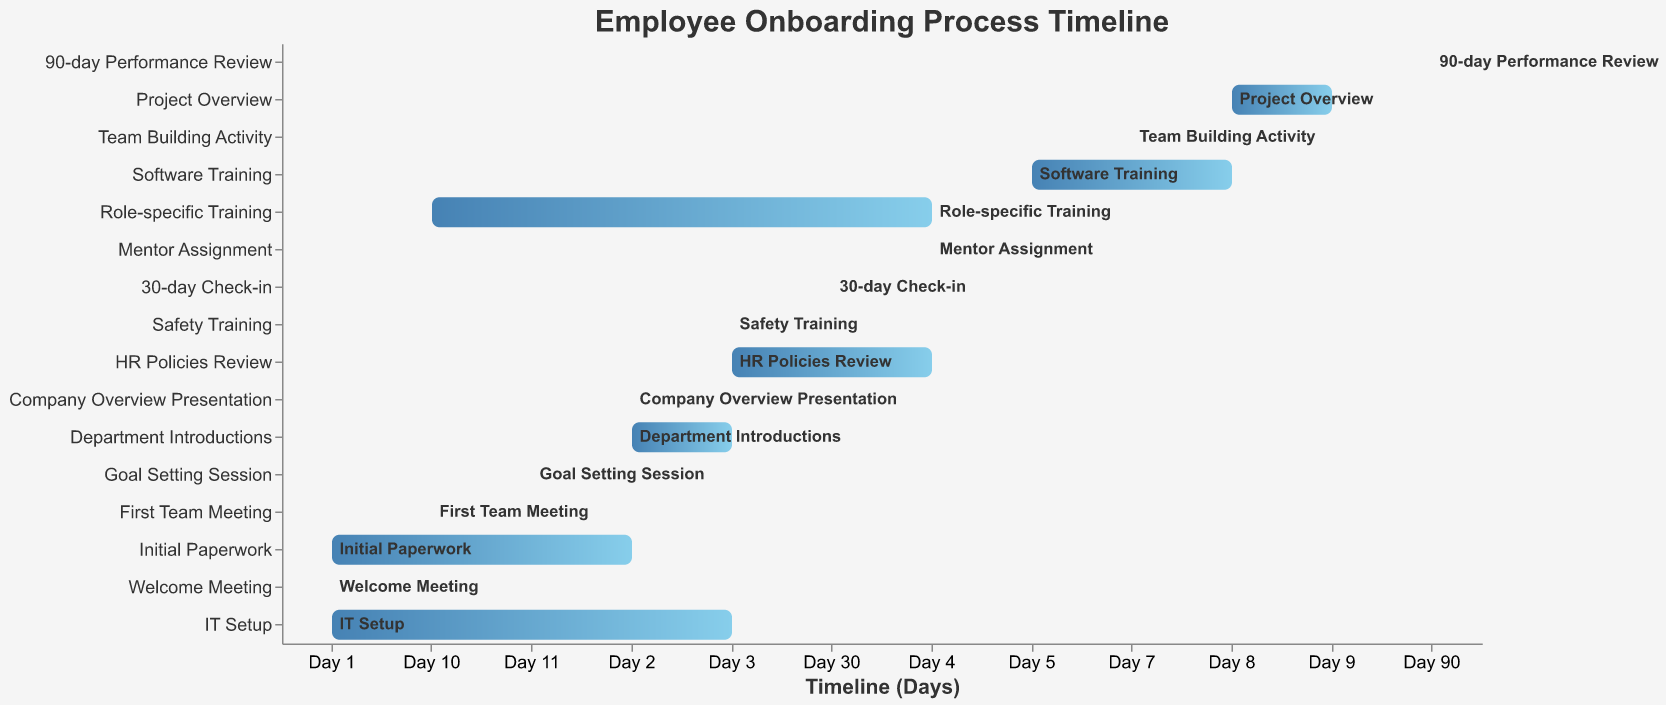What is the overall timeline for the employee onboarding process? The timeline for the employee onboarding process starts from "Day 1" and ends at "Day 90". We can see this by observing the start of the "Initial Paperwork" on Day 1 and the end of the "90-day Performance Review" on Day 90.
Answer: The timeline spans from Day 1 to Day 90 What tasks are scheduled to start on Day 1? By inspecting the Gantt Chart, we see that the tasks starting on Day 1 are "Initial Paperwork", "Welcome Meeting", and "IT Setup".
Answer: Initial Paperwork, Welcome Meeting, IT Setup Which tasks are completed in a single day? The tasks that start and end on the same day are "Welcome Meeting", "Company Overview Presentation", "Safety Training", "Mentor Assignment", "Team Building Activity", "First Team Meeting", and "Goal Setting Session".
Answer: Welcome Meeting, Company Overview Presentation, Safety Training, Mentor Assignment, Team Building Activity, First Team Meeting, Goal Setting Session How long does "Role-specific Training" take to complete? "Role-specific Training" starts on Day 4 and ends on Day 10, giving us a duration of 7 days.
Answer: 7 days Which tasks occur on Day 3? Tasks that occur on Day 3 include "IT Setup", "Department Introductions", "Safety Training", and "HR Policies Review".
Answer: IT Setup, Department Introductions, Safety Training, HR Policies Review Identify the tasks that are part of the "Training" stage. The tasks that fall under "Training" are likely those that involve specific instruction or learning. These include "Safety Training" (Day 3), "HR Policies Review" (Day 3-4), "Role-specific Training" (Day 4-10), and "Software Training" (Day 5-8).
Answer: Safety Training, HR Policies Review, Role-specific Training, Software Training Which tasks conclude before the start of "Software Training"? Tasks that conclude before "Software Training" begins on Day 5 are "Initial Paperwork", "Welcome Meeting", "IT Setup", "Company Overview Presentation", "Department Introductions", "Safety Training", "HR Policies Review", and "Mentor Assignment".
Answer: Initial Paperwork, Welcome Meeting, IT Setup, Company Overview Presentation, Department Introductions, Safety Training, HR Policies Review, Mentor Assignment When does the "30-day Check-in" take place? The "30-day Check-in" occurs on Day 30, as indicated by the timeline.
Answer: Day 30 Compare the durations of "Safety Training" and "Software Training". Which one is longer and by how many days? "Safety Training" lasts for 1 day (Day 3), while "Software Training" spans 4 days (Day 5 to Day 8). Therefore, "Software Training" is longer by 3 days.
Answer: Software Training is longer by 3 days How many tasks are scheduled to start on Day 4? On Day 4, the tasks starting are "Role-specific Training" and "Mentor Assignment". This gives us a total of 2 tasks.
Answer: 2 tasks 